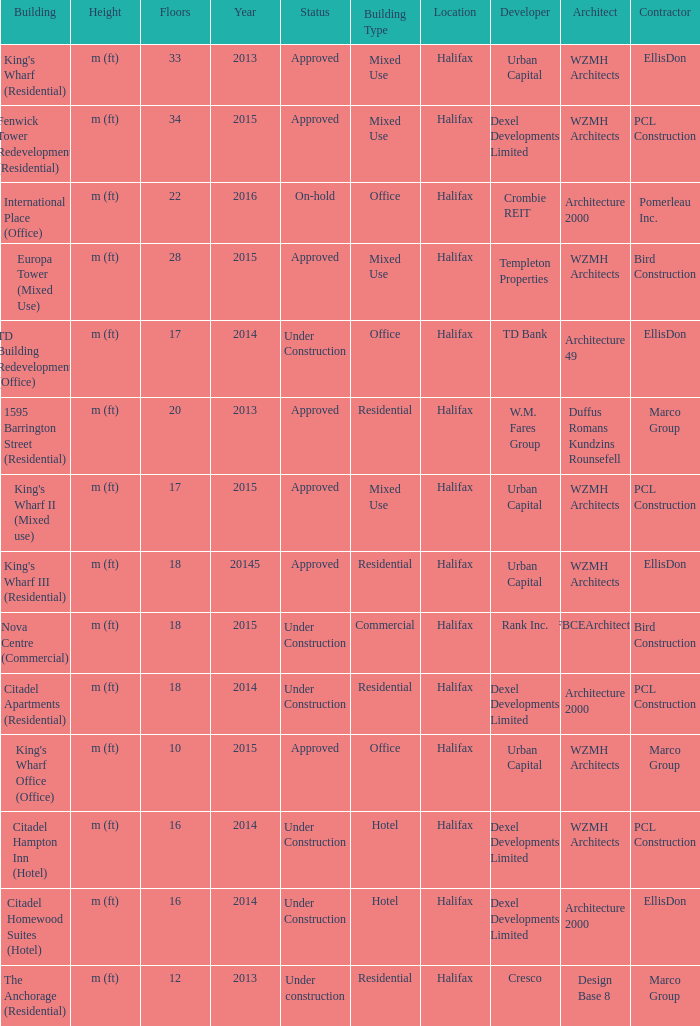What building shows 2013 and has more than 20 floors? King's Wharf (Residential). 